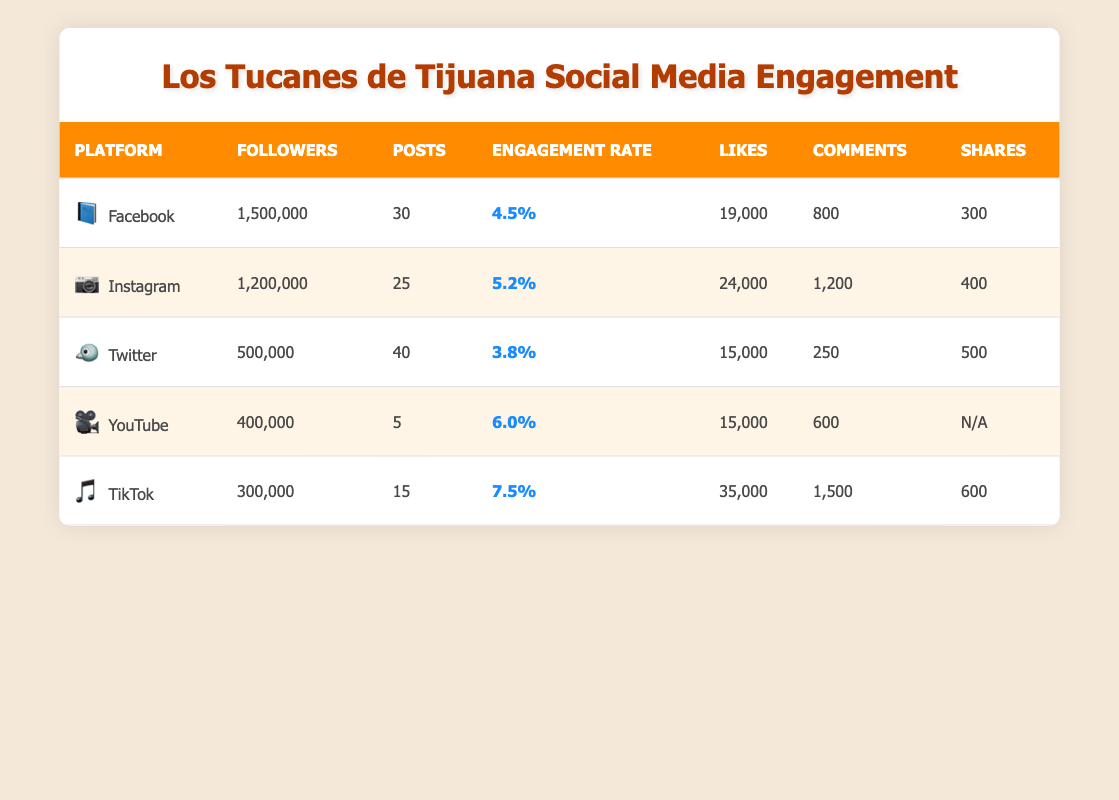What platform has the highest number of followers? By looking at the "Followers" column, Facebook has 1,500,000 followers, which is the highest compared to Instagram (1,200,000), Twitter (500,000), YouTube (400,000), and TikTok (300,000).
Answer: Facebook Which platform has the lowest engagement rate? The engagement rates are 4.5% for Facebook, 5.2% for Instagram, 3.8% for Twitter, 6.0% for YouTube, and 7.5% for TikTok. Among these, Twitter has the lowest engagement rate at 3.8%.
Answer: Twitter Calculate the total number of likes across all platforms. Adding the likes from each platform: Facebook (19,000) + Instagram (24,000) + Twitter (15,000) + YouTube (15,000) + TikTok (35,000) = 108,000.
Answer: 108,000 What is the difference in the number of posts between Instagram and TikTok? Instagram has 25 posts and TikTok has 15 posts. The difference is 25 - 15 = 10.
Answer: 10 Is the engagement rate on TikTok higher than on Facebook? TikTok's engagement rate is 7.5% and Facebook's is 4.5%. Since 7.5% is greater than 4.5%, this statement is true.
Answer: Yes Which platform had the most comments, and how many? Examining the "Comments" column: Facebook (800), Instagram (1,200), Twitter (250), YouTube (600), and TikTok (1,500). TikTok has the most comments at 1,500.
Answer: TikTok with 1,500 comments Identify the platform with the highest number of shares and its count. The shares are as follows: Facebook (300), Instagram (400), Twitter (500), YouTube (N/A), and TikTok (600). TikTok has the highest shares at 600.
Answer: TikTok with 600 shares Calculate the average engagement rate across all platforms. The engagement rates are 4.5%, 5.2%, 3.8%, 6.0%, and 7.5%. Adding these gives 27.0; dividing by 5 provides the average: 27.0 / 5 = 5.4%.
Answer: 5.4% Which platform had the fewest recently published videos? YouTube has 5 videos recently published, which is less than TikTok (15). Thus, YouTube had the fewest.
Answer: YouTube Was Los Tucanes de Tijuana more liked on TikTok or Instagram? Likes on TikTok are 35,000, while on Instagram they are 24,000. Since 35,000 is greater than 24,000, they were more liked on TikTok.
Answer: TikTok Does the data show that Los Tucanes de Tijuana has a significant presence on Twitter compared to Facebook? Facebook has 1,500,000 followers, while Twitter has only 500,000. This indicates that their presence on Twitter is not significant compared to Facebook.
Answer: No 